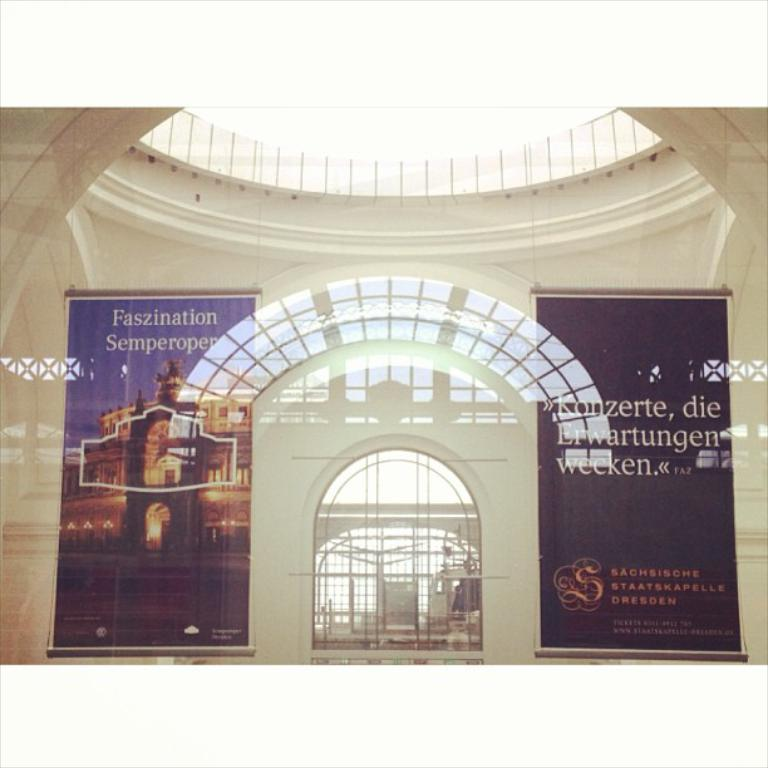What is the main subject of the image? The main subject of the image is an advertisement. What architectural feature can be seen in the image? There is a window in the image. What material is used for the window? Glass is present in the image. What type of structure is visible in the image? There is a wall in the image. Which direction is the knife pointing in the image? There is no knife present in the image. What causes a spark to appear in the image? There is no spark present in the image. 